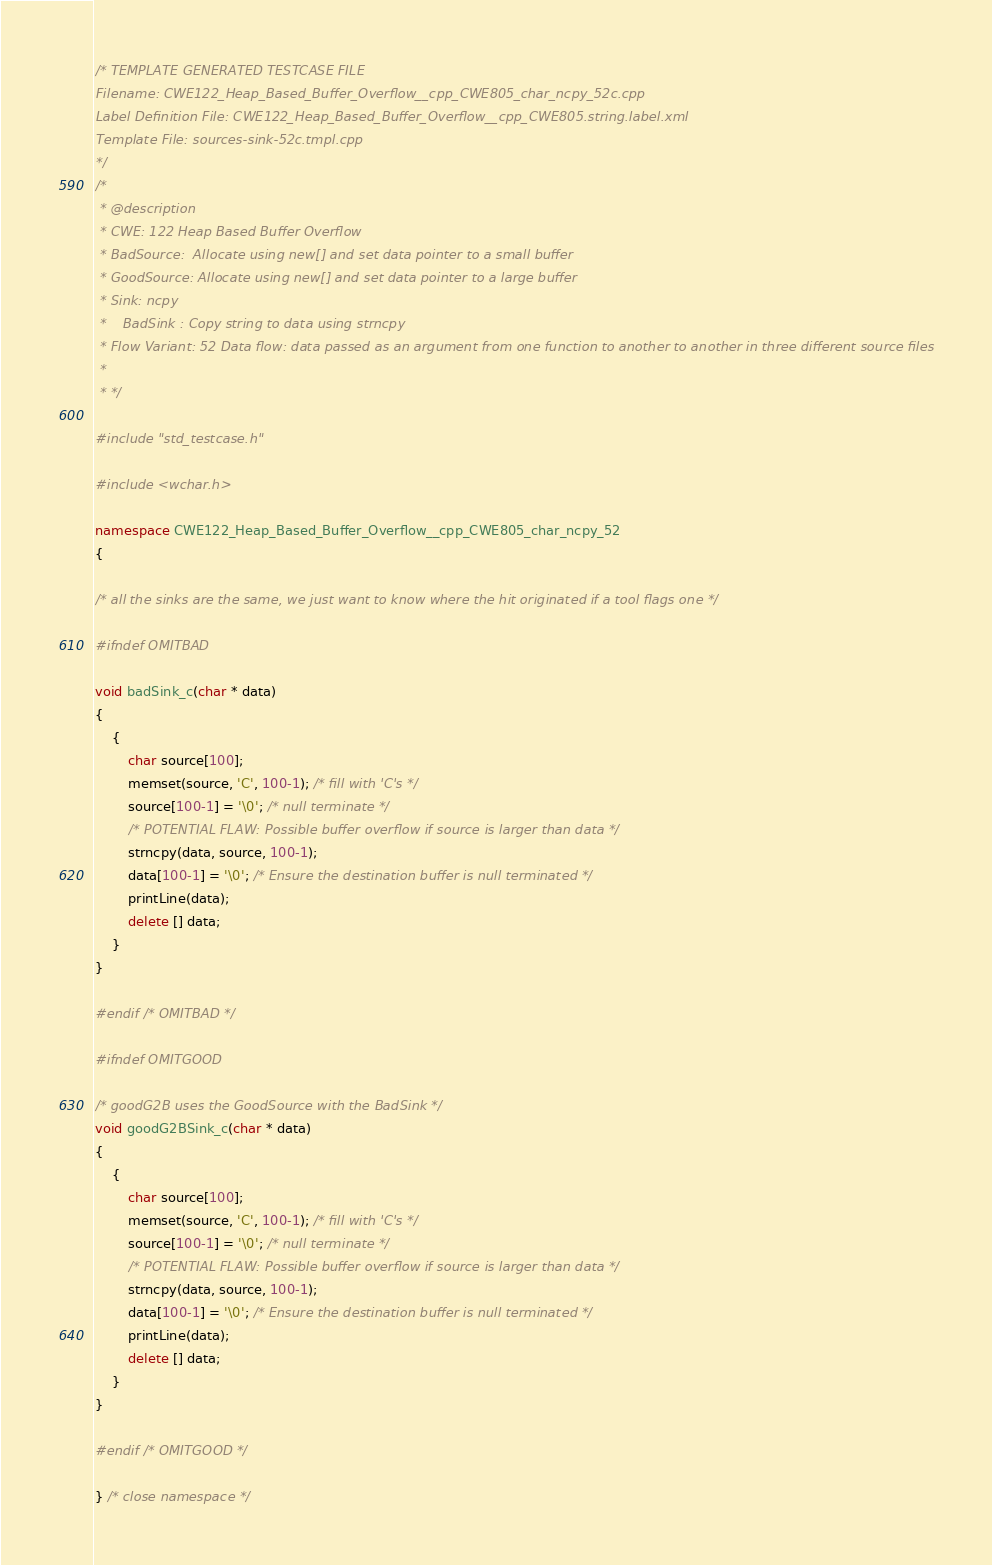<code> <loc_0><loc_0><loc_500><loc_500><_C++_>/* TEMPLATE GENERATED TESTCASE FILE
Filename: CWE122_Heap_Based_Buffer_Overflow__cpp_CWE805_char_ncpy_52c.cpp
Label Definition File: CWE122_Heap_Based_Buffer_Overflow__cpp_CWE805.string.label.xml
Template File: sources-sink-52c.tmpl.cpp
*/
/*
 * @description
 * CWE: 122 Heap Based Buffer Overflow
 * BadSource:  Allocate using new[] and set data pointer to a small buffer
 * GoodSource: Allocate using new[] and set data pointer to a large buffer
 * Sink: ncpy
 *    BadSink : Copy string to data using strncpy
 * Flow Variant: 52 Data flow: data passed as an argument from one function to another to another in three different source files
 *
 * */

#include "std_testcase.h"

#include <wchar.h>

namespace CWE122_Heap_Based_Buffer_Overflow__cpp_CWE805_char_ncpy_52
{

/* all the sinks are the same, we just want to know where the hit originated if a tool flags one */

#ifndef OMITBAD

void badSink_c(char * data)
{
    {
        char source[100];
        memset(source, 'C', 100-1); /* fill with 'C's */
        source[100-1] = '\0'; /* null terminate */
        /* POTENTIAL FLAW: Possible buffer overflow if source is larger than data */
        strncpy(data, source, 100-1);
        data[100-1] = '\0'; /* Ensure the destination buffer is null terminated */
        printLine(data);
        delete [] data;
    }
}

#endif /* OMITBAD */

#ifndef OMITGOOD

/* goodG2B uses the GoodSource with the BadSink */
void goodG2BSink_c(char * data)
{
    {
        char source[100];
        memset(source, 'C', 100-1); /* fill with 'C's */
        source[100-1] = '\0'; /* null terminate */
        /* POTENTIAL FLAW: Possible buffer overflow if source is larger than data */
        strncpy(data, source, 100-1);
        data[100-1] = '\0'; /* Ensure the destination buffer is null terminated */
        printLine(data);
        delete [] data;
    }
}

#endif /* OMITGOOD */

} /* close namespace */
</code> 